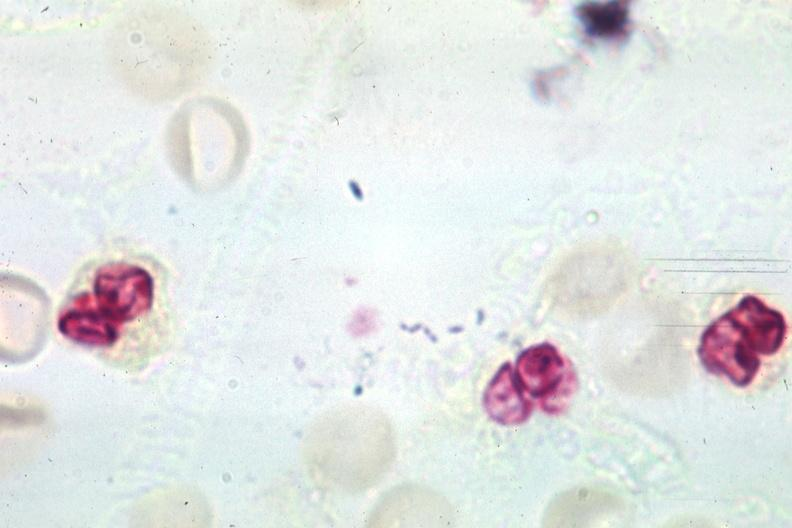what is present?
Answer the question using a single word or phrase. Spinal fluid 